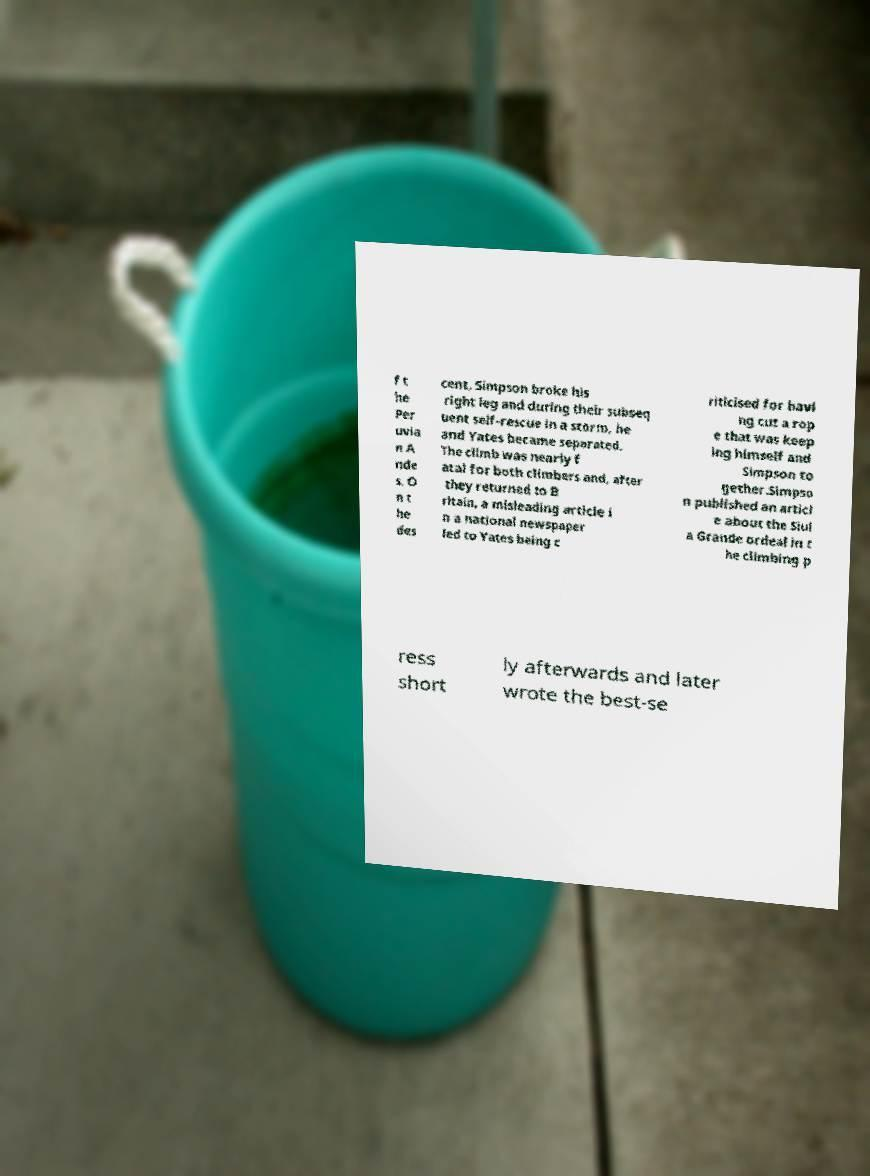For documentation purposes, I need the text within this image transcribed. Could you provide that? f t he Per uvia n A nde s. O n t he des cent, Simpson broke his right leg and during their subseq uent self-rescue in a storm, he and Yates became separated. The climb was nearly f atal for both climbers and, after they returned to B ritain, a misleading article i n a national newspaper led to Yates being c riticised for havi ng cut a rop e that was keep ing himself and Simpson to gether.Simpso n published an articl e about the Siul a Grande ordeal in t he climbing p ress short ly afterwards and later wrote the best-se 